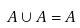Convert formula to latex. <formula><loc_0><loc_0><loc_500><loc_500>A \cup A = A</formula> 